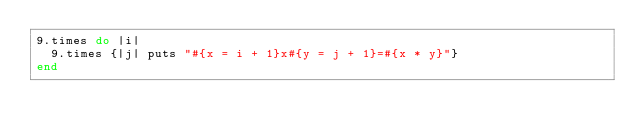Convert code to text. <code><loc_0><loc_0><loc_500><loc_500><_Ruby_>9.times do |i|
  9.times {|j| puts "#{x = i + 1}x#{y = j + 1}=#{x * y}"}
end
</code> 